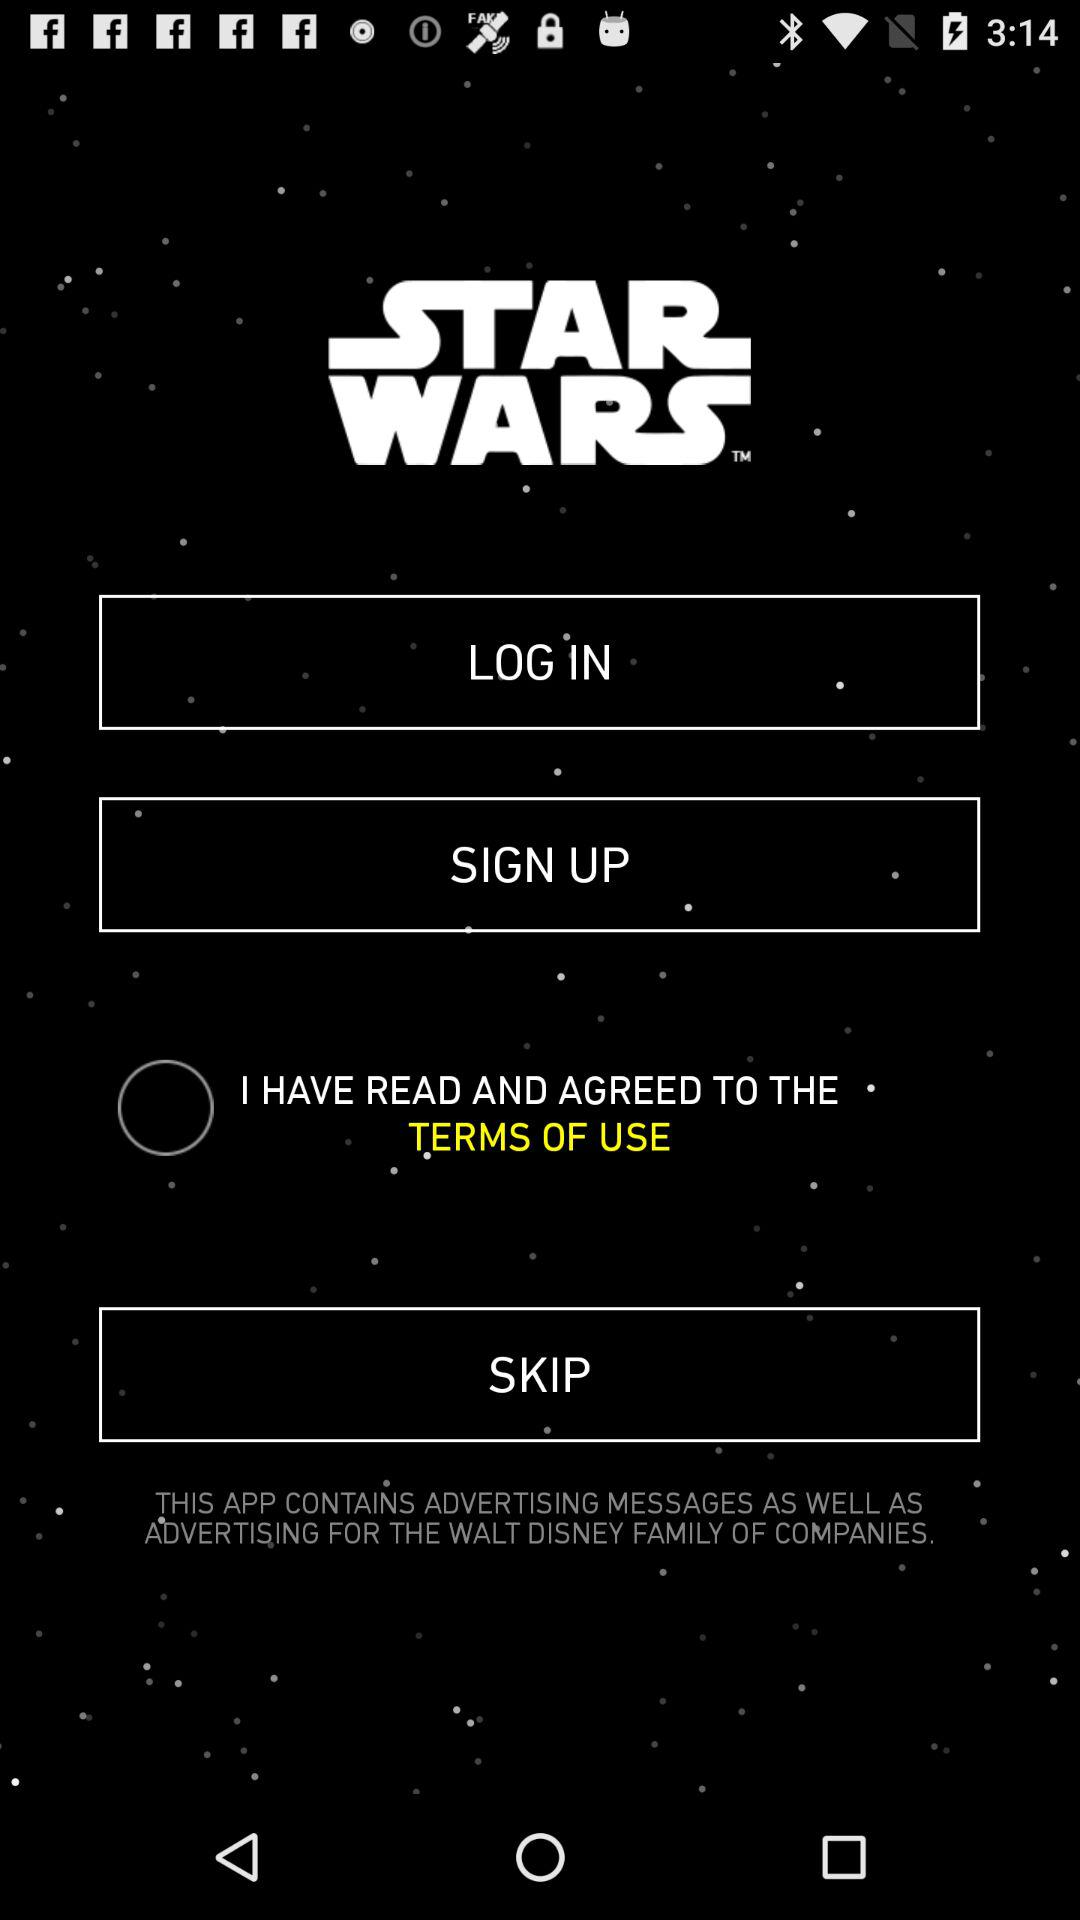What is the application name? The application name is "STAR WARS". 